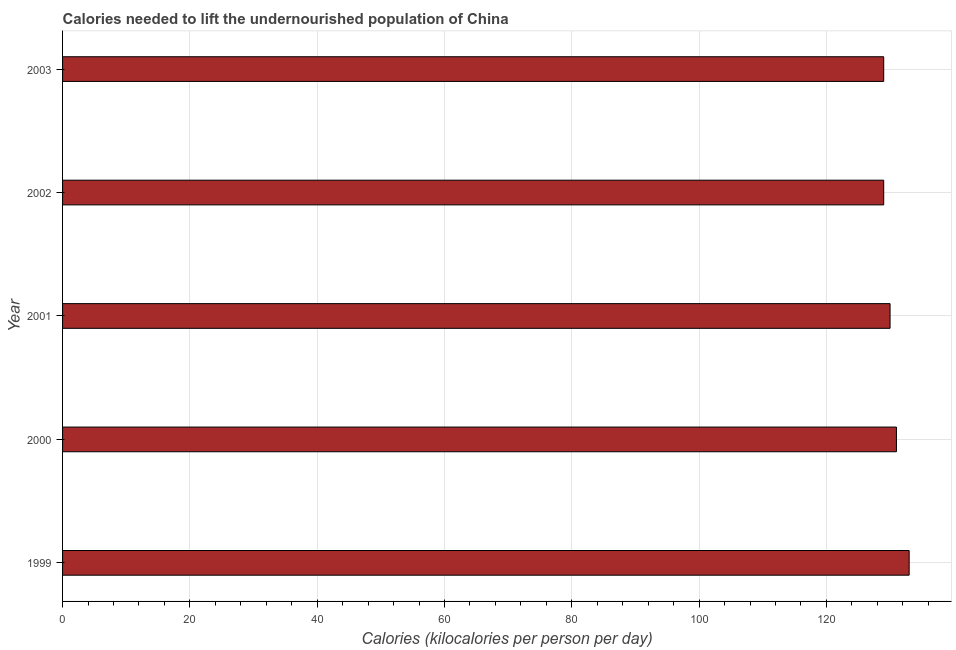Does the graph contain any zero values?
Your response must be concise. No. What is the title of the graph?
Provide a short and direct response. Calories needed to lift the undernourished population of China. What is the label or title of the X-axis?
Offer a terse response. Calories (kilocalories per person per day). What is the label or title of the Y-axis?
Your response must be concise. Year. What is the depth of food deficit in 2000?
Give a very brief answer. 131. Across all years, what is the maximum depth of food deficit?
Keep it short and to the point. 133. Across all years, what is the minimum depth of food deficit?
Offer a terse response. 129. In which year was the depth of food deficit minimum?
Make the answer very short. 2002. What is the sum of the depth of food deficit?
Keep it short and to the point. 652. What is the average depth of food deficit per year?
Provide a short and direct response. 130. What is the median depth of food deficit?
Offer a terse response. 130. In how many years, is the depth of food deficit greater than 116 kilocalories?
Offer a very short reply. 5. Do a majority of the years between 1999 and 2000 (inclusive) have depth of food deficit greater than 128 kilocalories?
Keep it short and to the point. Yes. What is the ratio of the depth of food deficit in 2001 to that in 2003?
Ensure brevity in your answer.  1.01. Is the depth of food deficit in 1999 less than that in 2001?
Provide a short and direct response. No. Is the difference between the depth of food deficit in 2002 and 2003 greater than the difference between any two years?
Provide a short and direct response. No. What is the difference between the highest and the second highest depth of food deficit?
Make the answer very short. 2. Is the sum of the depth of food deficit in 1999 and 2002 greater than the maximum depth of food deficit across all years?
Ensure brevity in your answer.  Yes. How many bars are there?
Provide a short and direct response. 5. What is the difference between two consecutive major ticks on the X-axis?
Offer a terse response. 20. Are the values on the major ticks of X-axis written in scientific E-notation?
Your answer should be very brief. No. What is the Calories (kilocalories per person per day) of 1999?
Your answer should be very brief. 133. What is the Calories (kilocalories per person per day) in 2000?
Make the answer very short. 131. What is the Calories (kilocalories per person per day) of 2001?
Offer a very short reply. 130. What is the Calories (kilocalories per person per day) in 2002?
Provide a short and direct response. 129. What is the Calories (kilocalories per person per day) in 2003?
Make the answer very short. 129. What is the difference between the Calories (kilocalories per person per day) in 1999 and 2000?
Keep it short and to the point. 2. What is the difference between the Calories (kilocalories per person per day) in 1999 and 2001?
Your response must be concise. 3. What is the difference between the Calories (kilocalories per person per day) in 2000 and 2001?
Your response must be concise. 1. What is the difference between the Calories (kilocalories per person per day) in 2000 and 2003?
Your answer should be very brief. 2. What is the difference between the Calories (kilocalories per person per day) in 2001 and 2003?
Offer a terse response. 1. What is the difference between the Calories (kilocalories per person per day) in 2002 and 2003?
Your response must be concise. 0. What is the ratio of the Calories (kilocalories per person per day) in 1999 to that in 2001?
Provide a short and direct response. 1.02. What is the ratio of the Calories (kilocalories per person per day) in 1999 to that in 2002?
Keep it short and to the point. 1.03. What is the ratio of the Calories (kilocalories per person per day) in 1999 to that in 2003?
Give a very brief answer. 1.03. What is the ratio of the Calories (kilocalories per person per day) in 2001 to that in 2003?
Make the answer very short. 1.01. 